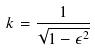<formula> <loc_0><loc_0><loc_500><loc_500>k = \frac { 1 } { \sqrt { 1 - \epsilon ^ { 2 } } }</formula> 